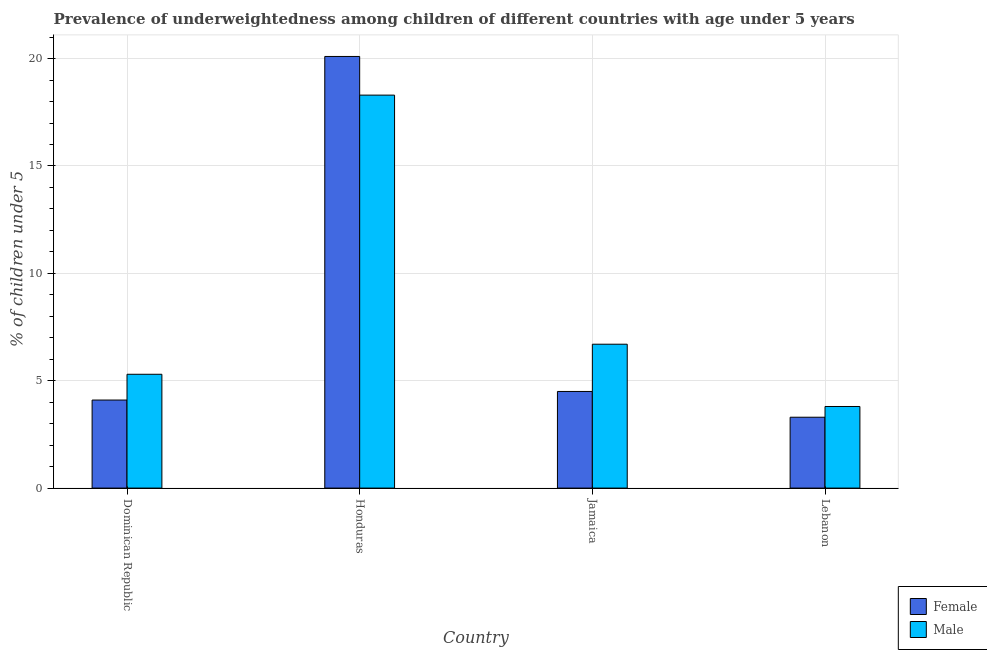How many different coloured bars are there?
Provide a succinct answer. 2. Are the number of bars per tick equal to the number of legend labels?
Offer a very short reply. Yes. How many bars are there on the 3rd tick from the right?
Provide a short and direct response. 2. What is the label of the 3rd group of bars from the left?
Keep it short and to the point. Jamaica. What is the percentage of underweighted male children in Honduras?
Provide a short and direct response. 18.3. Across all countries, what is the maximum percentage of underweighted male children?
Give a very brief answer. 18.3. Across all countries, what is the minimum percentage of underweighted male children?
Your answer should be very brief. 3.8. In which country was the percentage of underweighted female children maximum?
Your response must be concise. Honduras. In which country was the percentage of underweighted female children minimum?
Your answer should be very brief. Lebanon. What is the total percentage of underweighted male children in the graph?
Your answer should be compact. 34.1. What is the difference between the percentage of underweighted female children in Jamaica and that in Lebanon?
Your answer should be compact. 1.2. What is the difference between the percentage of underweighted female children in Jamaica and the percentage of underweighted male children in Dominican Republic?
Your answer should be compact. -0.8. What is the average percentage of underweighted female children per country?
Provide a succinct answer. 8. What is the ratio of the percentage of underweighted male children in Jamaica to that in Lebanon?
Provide a short and direct response. 1.76. What is the difference between the highest and the second highest percentage of underweighted female children?
Your answer should be compact. 15.6. What is the difference between the highest and the lowest percentage of underweighted female children?
Your answer should be very brief. 16.8. In how many countries, is the percentage of underweighted female children greater than the average percentage of underweighted female children taken over all countries?
Offer a terse response. 1. What does the 1st bar from the left in Lebanon represents?
Your response must be concise. Female. Are all the bars in the graph horizontal?
Your response must be concise. No. Does the graph contain any zero values?
Offer a very short reply. No. Where does the legend appear in the graph?
Your answer should be very brief. Bottom right. How many legend labels are there?
Make the answer very short. 2. What is the title of the graph?
Your answer should be compact. Prevalence of underweightedness among children of different countries with age under 5 years. What is the label or title of the Y-axis?
Ensure brevity in your answer.   % of children under 5. What is the  % of children under 5 of Female in Dominican Republic?
Offer a terse response. 4.1. What is the  % of children under 5 of Male in Dominican Republic?
Give a very brief answer. 5.3. What is the  % of children under 5 of Female in Honduras?
Your answer should be compact. 20.1. What is the  % of children under 5 in Male in Honduras?
Provide a short and direct response. 18.3. What is the  % of children under 5 of Female in Jamaica?
Your answer should be very brief. 4.5. What is the  % of children under 5 of Male in Jamaica?
Keep it short and to the point. 6.7. What is the  % of children under 5 of Female in Lebanon?
Ensure brevity in your answer.  3.3. What is the  % of children under 5 in Male in Lebanon?
Keep it short and to the point. 3.8. Across all countries, what is the maximum  % of children under 5 in Female?
Your answer should be very brief. 20.1. Across all countries, what is the maximum  % of children under 5 of Male?
Keep it short and to the point. 18.3. Across all countries, what is the minimum  % of children under 5 in Female?
Make the answer very short. 3.3. Across all countries, what is the minimum  % of children under 5 of Male?
Make the answer very short. 3.8. What is the total  % of children under 5 of Male in the graph?
Provide a succinct answer. 34.1. What is the difference between the  % of children under 5 in Female in Dominican Republic and that in Honduras?
Make the answer very short. -16. What is the difference between the  % of children under 5 in Female in Dominican Republic and that in Jamaica?
Ensure brevity in your answer.  -0.4. What is the difference between the  % of children under 5 of Female in Dominican Republic and that in Lebanon?
Make the answer very short. 0.8. What is the difference between the  % of children under 5 in Male in Honduras and that in Jamaica?
Provide a short and direct response. 11.6. What is the difference between the  % of children under 5 of Female in Dominican Republic and the  % of children under 5 of Male in Honduras?
Offer a very short reply. -14.2. What is the difference between the  % of children under 5 of Female in Dominican Republic and the  % of children under 5 of Male in Jamaica?
Offer a terse response. -2.6. What is the difference between the  % of children under 5 of Female in Dominican Republic and the  % of children under 5 of Male in Lebanon?
Your answer should be compact. 0.3. What is the difference between the  % of children under 5 in Female in Honduras and the  % of children under 5 in Male in Jamaica?
Your answer should be compact. 13.4. What is the difference between the  % of children under 5 of Female in Honduras and the  % of children under 5 of Male in Lebanon?
Provide a short and direct response. 16.3. What is the average  % of children under 5 in Female per country?
Provide a succinct answer. 8. What is the average  % of children under 5 of Male per country?
Keep it short and to the point. 8.53. What is the difference between the  % of children under 5 in Female and  % of children under 5 in Male in Dominican Republic?
Your answer should be compact. -1.2. What is the difference between the  % of children under 5 in Female and  % of children under 5 in Male in Honduras?
Offer a very short reply. 1.8. What is the ratio of the  % of children under 5 of Female in Dominican Republic to that in Honduras?
Your answer should be very brief. 0.2. What is the ratio of the  % of children under 5 in Male in Dominican Republic to that in Honduras?
Offer a very short reply. 0.29. What is the ratio of the  % of children under 5 of Female in Dominican Republic to that in Jamaica?
Offer a very short reply. 0.91. What is the ratio of the  % of children under 5 in Male in Dominican Republic to that in Jamaica?
Offer a terse response. 0.79. What is the ratio of the  % of children under 5 in Female in Dominican Republic to that in Lebanon?
Ensure brevity in your answer.  1.24. What is the ratio of the  % of children under 5 of Male in Dominican Republic to that in Lebanon?
Keep it short and to the point. 1.39. What is the ratio of the  % of children under 5 in Female in Honduras to that in Jamaica?
Give a very brief answer. 4.47. What is the ratio of the  % of children under 5 in Male in Honduras to that in Jamaica?
Offer a terse response. 2.73. What is the ratio of the  % of children under 5 of Female in Honduras to that in Lebanon?
Your answer should be very brief. 6.09. What is the ratio of the  % of children under 5 in Male in Honduras to that in Lebanon?
Your response must be concise. 4.82. What is the ratio of the  % of children under 5 in Female in Jamaica to that in Lebanon?
Provide a succinct answer. 1.36. What is the ratio of the  % of children under 5 in Male in Jamaica to that in Lebanon?
Provide a succinct answer. 1.76. What is the difference between the highest and the lowest  % of children under 5 in Female?
Ensure brevity in your answer.  16.8. What is the difference between the highest and the lowest  % of children under 5 of Male?
Ensure brevity in your answer.  14.5. 